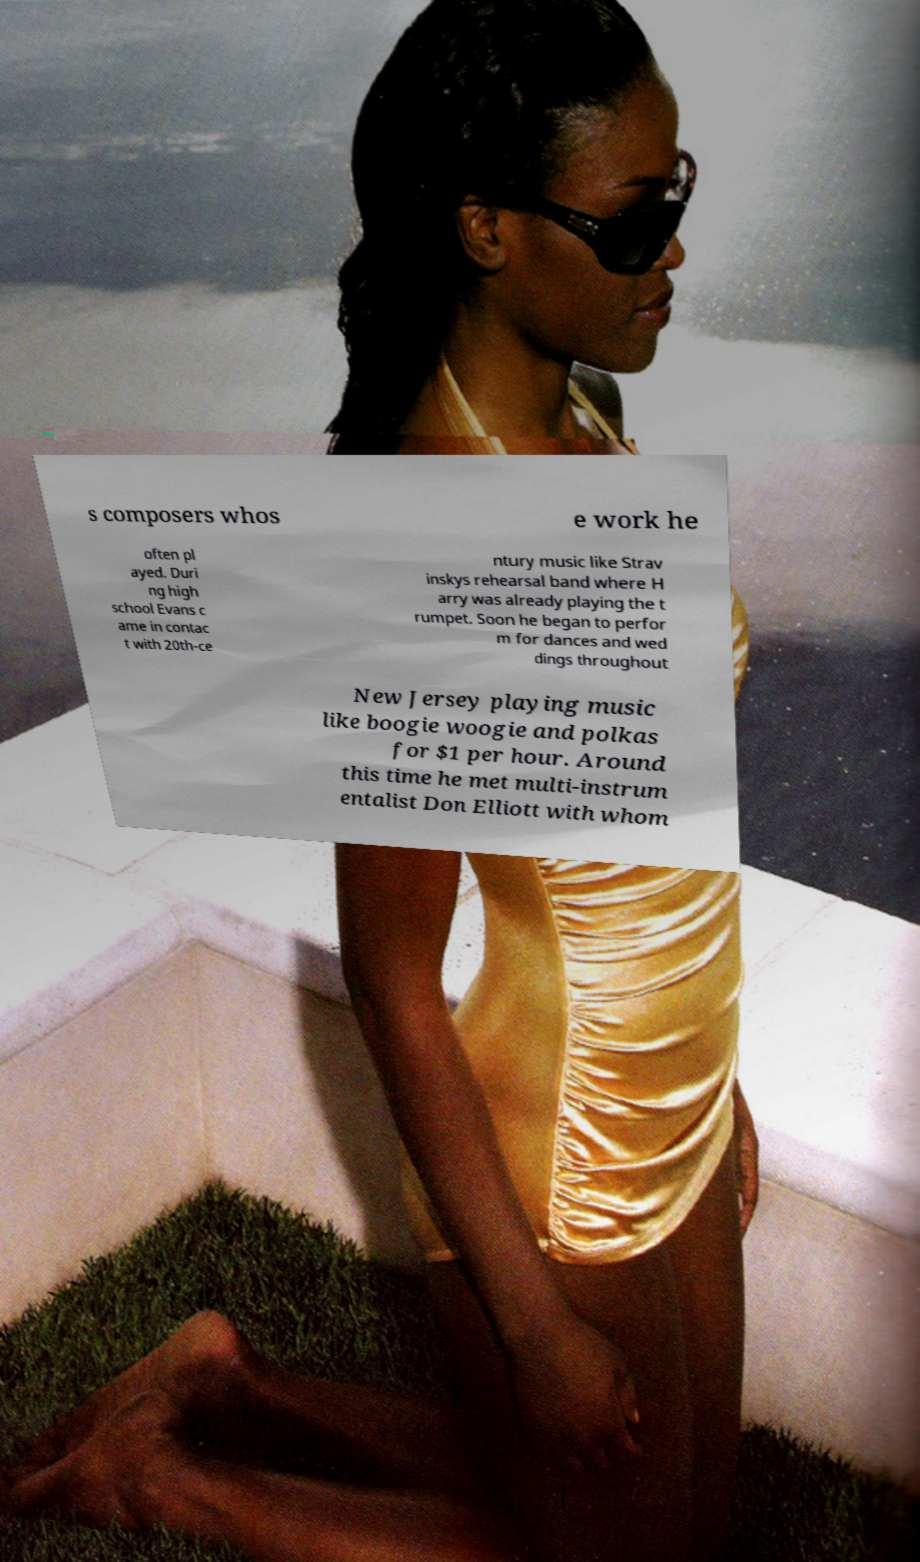Could you assist in decoding the text presented in this image and type it out clearly? s composers whos e work he often pl ayed. Duri ng high school Evans c ame in contac t with 20th-ce ntury music like Strav inskys rehearsal band where H arry was already playing the t rumpet. Soon he began to perfor m for dances and wed dings throughout New Jersey playing music like boogie woogie and polkas for $1 per hour. Around this time he met multi-instrum entalist Don Elliott with whom 